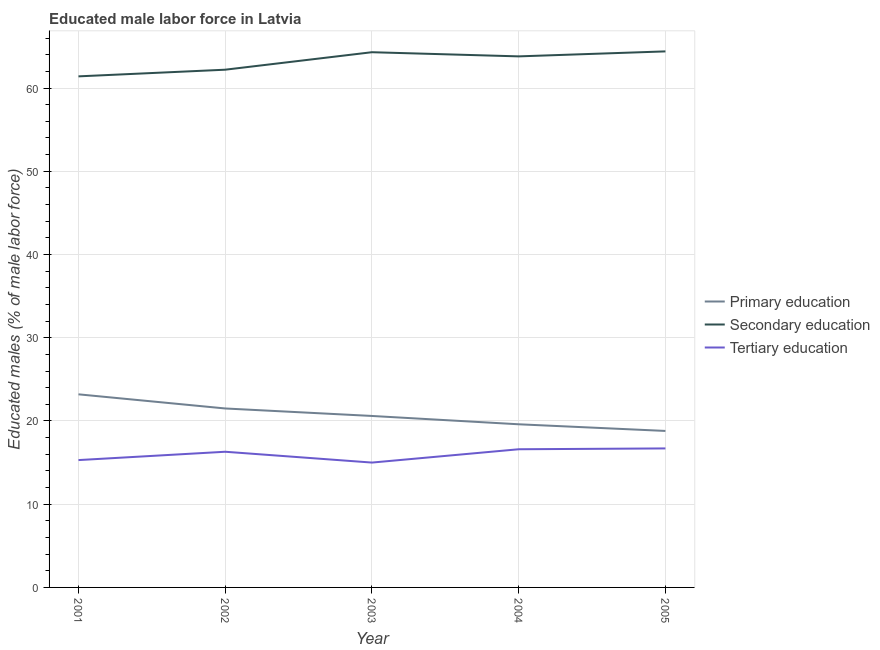Is the number of lines equal to the number of legend labels?
Provide a short and direct response. Yes. What is the percentage of male labor force who received secondary education in 2005?
Make the answer very short. 64.4. Across all years, what is the maximum percentage of male labor force who received primary education?
Your answer should be very brief. 23.2. Across all years, what is the minimum percentage of male labor force who received secondary education?
Keep it short and to the point. 61.4. In which year was the percentage of male labor force who received primary education maximum?
Offer a terse response. 2001. What is the total percentage of male labor force who received tertiary education in the graph?
Your response must be concise. 79.9. What is the difference between the percentage of male labor force who received secondary education in 2001 and that in 2003?
Ensure brevity in your answer.  -2.9. What is the difference between the percentage of male labor force who received tertiary education in 2004 and the percentage of male labor force who received secondary education in 2002?
Provide a short and direct response. -45.6. What is the average percentage of male labor force who received tertiary education per year?
Your answer should be compact. 15.98. In the year 2002, what is the difference between the percentage of male labor force who received primary education and percentage of male labor force who received secondary education?
Your response must be concise. -40.7. What is the ratio of the percentage of male labor force who received tertiary education in 2002 to that in 2005?
Ensure brevity in your answer.  0.98. Is the percentage of male labor force who received tertiary education in 2001 less than that in 2005?
Provide a succinct answer. Yes. What is the difference between the highest and the second highest percentage of male labor force who received tertiary education?
Keep it short and to the point. 0.1. What is the difference between the highest and the lowest percentage of male labor force who received tertiary education?
Keep it short and to the point. 1.7. In how many years, is the percentage of male labor force who received primary education greater than the average percentage of male labor force who received primary education taken over all years?
Give a very brief answer. 2. Is the sum of the percentage of male labor force who received tertiary education in 2002 and 2004 greater than the maximum percentage of male labor force who received secondary education across all years?
Provide a short and direct response. No. Does the percentage of male labor force who received tertiary education monotonically increase over the years?
Keep it short and to the point. No. Is the percentage of male labor force who received secondary education strictly less than the percentage of male labor force who received primary education over the years?
Offer a terse response. No. How many years are there in the graph?
Offer a very short reply. 5. What is the difference between two consecutive major ticks on the Y-axis?
Provide a short and direct response. 10. Are the values on the major ticks of Y-axis written in scientific E-notation?
Provide a succinct answer. No. Where does the legend appear in the graph?
Make the answer very short. Center right. How are the legend labels stacked?
Your response must be concise. Vertical. What is the title of the graph?
Provide a succinct answer. Educated male labor force in Latvia. What is the label or title of the X-axis?
Make the answer very short. Year. What is the label or title of the Y-axis?
Provide a short and direct response. Educated males (% of male labor force). What is the Educated males (% of male labor force) of Primary education in 2001?
Ensure brevity in your answer.  23.2. What is the Educated males (% of male labor force) of Secondary education in 2001?
Ensure brevity in your answer.  61.4. What is the Educated males (% of male labor force) of Tertiary education in 2001?
Offer a very short reply. 15.3. What is the Educated males (% of male labor force) of Primary education in 2002?
Give a very brief answer. 21.5. What is the Educated males (% of male labor force) of Secondary education in 2002?
Offer a terse response. 62.2. What is the Educated males (% of male labor force) in Tertiary education in 2002?
Keep it short and to the point. 16.3. What is the Educated males (% of male labor force) of Primary education in 2003?
Give a very brief answer. 20.6. What is the Educated males (% of male labor force) in Secondary education in 2003?
Your answer should be compact. 64.3. What is the Educated males (% of male labor force) in Tertiary education in 2003?
Offer a very short reply. 15. What is the Educated males (% of male labor force) of Primary education in 2004?
Keep it short and to the point. 19.6. What is the Educated males (% of male labor force) in Secondary education in 2004?
Provide a succinct answer. 63.8. What is the Educated males (% of male labor force) of Tertiary education in 2004?
Keep it short and to the point. 16.6. What is the Educated males (% of male labor force) of Primary education in 2005?
Offer a very short reply. 18.8. What is the Educated males (% of male labor force) of Secondary education in 2005?
Your answer should be compact. 64.4. What is the Educated males (% of male labor force) of Tertiary education in 2005?
Make the answer very short. 16.7. Across all years, what is the maximum Educated males (% of male labor force) of Primary education?
Offer a terse response. 23.2. Across all years, what is the maximum Educated males (% of male labor force) in Secondary education?
Offer a terse response. 64.4. Across all years, what is the maximum Educated males (% of male labor force) of Tertiary education?
Make the answer very short. 16.7. Across all years, what is the minimum Educated males (% of male labor force) in Primary education?
Your answer should be compact. 18.8. Across all years, what is the minimum Educated males (% of male labor force) of Secondary education?
Your response must be concise. 61.4. What is the total Educated males (% of male labor force) in Primary education in the graph?
Your answer should be compact. 103.7. What is the total Educated males (% of male labor force) of Secondary education in the graph?
Give a very brief answer. 316.1. What is the total Educated males (% of male labor force) of Tertiary education in the graph?
Your answer should be compact. 79.9. What is the difference between the Educated males (% of male labor force) in Primary education in 2001 and that in 2002?
Your response must be concise. 1.7. What is the difference between the Educated males (% of male labor force) of Secondary education in 2001 and that in 2002?
Give a very brief answer. -0.8. What is the difference between the Educated males (% of male labor force) of Tertiary education in 2001 and that in 2002?
Offer a very short reply. -1. What is the difference between the Educated males (% of male labor force) in Tertiary education in 2001 and that in 2003?
Keep it short and to the point. 0.3. What is the difference between the Educated males (% of male labor force) of Secondary education in 2002 and that in 2003?
Keep it short and to the point. -2.1. What is the difference between the Educated males (% of male labor force) in Tertiary education in 2002 and that in 2003?
Provide a short and direct response. 1.3. What is the difference between the Educated males (% of male labor force) of Tertiary education in 2002 and that in 2004?
Offer a terse response. -0.3. What is the difference between the Educated males (% of male labor force) of Secondary education in 2002 and that in 2005?
Ensure brevity in your answer.  -2.2. What is the difference between the Educated males (% of male labor force) of Primary education in 2003 and that in 2004?
Provide a short and direct response. 1. What is the difference between the Educated males (% of male labor force) in Secondary education in 2003 and that in 2004?
Offer a very short reply. 0.5. What is the difference between the Educated males (% of male labor force) of Tertiary education in 2003 and that in 2004?
Make the answer very short. -1.6. What is the difference between the Educated males (% of male labor force) of Primary education in 2003 and that in 2005?
Your answer should be very brief. 1.8. What is the difference between the Educated males (% of male labor force) of Secondary education in 2003 and that in 2005?
Provide a short and direct response. -0.1. What is the difference between the Educated males (% of male labor force) in Tertiary education in 2003 and that in 2005?
Make the answer very short. -1.7. What is the difference between the Educated males (% of male labor force) of Primary education in 2004 and that in 2005?
Offer a very short reply. 0.8. What is the difference between the Educated males (% of male labor force) in Tertiary education in 2004 and that in 2005?
Offer a very short reply. -0.1. What is the difference between the Educated males (% of male labor force) of Primary education in 2001 and the Educated males (% of male labor force) of Secondary education in 2002?
Keep it short and to the point. -39. What is the difference between the Educated males (% of male labor force) of Secondary education in 2001 and the Educated males (% of male labor force) of Tertiary education in 2002?
Give a very brief answer. 45.1. What is the difference between the Educated males (% of male labor force) of Primary education in 2001 and the Educated males (% of male labor force) of Secondary education in 2003?
Provide a short and direct response. -41.1. What is the difference between the Educated males (% of male labor force) in Primary education in 2001 and the Educated males (% of male labor force) in Tertiary education in 2003?
Provide a short and direct response. 8.2. What is the difference between the Educated males (% of male labor force) in Secondary education in 2001 and the Educated males (% of male labor force) in Tertiary education in 2003?
Provide a short and direct response. 46.4. What is the difference between the Educated males (% of male labor force) in Primary education in 2001 and the Educated males (% of male labor force) in Secondary education in 2004?
Give a very brief answer. -40.6. What is the difference between the Educated males (% of male labor force) of Secondary education in 2001 and the Educated males (% of male labor force) of Tertiary education in 2004?
Your answer should be compact. 44.8. What is the difference between the Educated males (% of male labor force) in Primary education in 2001 and the Educated males (% of male labor force) in Secondary education in 2005?
Offer a very short reply. -41.2. What is the difference between the Educated males (% of male labor force) of Primary education in 2001 and the Educated males (% of male labor force) of Tertiary education in 2005?
Your answer should be very brief. 6.5. What is the difference between the Educated males (% of male labor force) in Secondary education in 2001 and the Educated males (% of male labor force) in Tertiary education in 2005?
Provide a short and direct response. 44.7. What is the difference between the Educated males (% of male labor force) of Primary education in 2002 and the Educated males (% of male labor force) of Secondary education in 2003?
Your answer should be very brief. -42.8. What is the difference between the Educated males (% of male labor force) of Primary education in 2002 and the Educated males (% of male labor force) of Tertiary education in 2003?
Ensure brevity in your answer.  6.5. What is the difference between the Educated males (% of male labor force) in Secondary education in 2002 and the Educated males (% of male labor force) in Tertiary education in 2003?
Keep it short and to the point. 47.2. What is the difference between the Educated males (% of male labor force) in Primary education in 2002 and the Educated males (% of male labor force) in Secondary education in 2004?
Offer a terse response. -42.3. What is the difference between the Educated males (% of male labor force) of Secondary education in 2002 and the Educated males (% of male labor force) of Tertiary education in 2004?
Give a very brief answer. 45.6. What is the difference between the Educated males (% of male labor force) of Primary education in 2002 and the Educated males (% of male labor force) of Secondary education in 2005?
Keep it short and to the point. -42.9. What is the difference between the Educated males (% of male labor force) in Secondary education in 2002 and the Educated males (% of male labor force) in Tertiary education in 2005?
Your answer should be compact. 45.5. What is the difference between the Educated males (% of male labor force) of Primary education in 2003 and the Educated males (% of male labor force) of Secondary education in 2004?
Make the answer very short. -43.2. What is the difference between the Educated males (% of male labor force) in Secondary education in 2003 and the Educated males (% of male labor force) in Tertiary education in 2004?
Offer a terse response. 47.7. What is the difference between the Educated males (% of male labor force) in Primary education in 2003 and the Educated males (% of male labor force) in Secondary education in 2005?
Your response must be concise. -43.8. What is the difference between the Educated males (% of male labor force) in Secondary education in 2003 and the Educated males (% of male labor force) in Tertiary education in 2005?
Your response must be concise. 47.6. What is the difference between the Educated males (% of male labor force) of Primary education in 2004 and the Educated males (% of male labor force) of Secondary education in 2005?
Your answer should be compact. -44.8. What is the difference between the Educated males (% of male labor force) in Secondary education in 2004 and the Educated males (% of male labor force) in Tertiary education in 2005?
Give a very brief answer. 47.1. What is the average Educated males (% of male labor force) of Primary education per year?
Your answer should be compact. 20.74. What is the average Educated males (% of male labor force) of Secondary education per year?
Provide a short and direct response. 63.22. What is the average Educated males (% of male labor force) of Tertiary education per year?
Ensure brevity in your answer.  15.98. In the year 2001, what is the difference between the Educated males (% of male labor force) of Primary education and Educated males (% of male labor force) of Secondary education?
Provide a succinct answer. -38.2. In the year 2001, what is the difference between the Educated males (% of male labor force) in Primary education and Educated males (% of male labor force) in Tertiary education?
Provide a succinct answer. 7.9. In the year 2001, what is the difference between the Educated males (% of male labor force) of Secondary education and Educated males (% of male labor force) of Tertiary education?
Make the answer very short. 46.1. In the year 2002, what is the difference between the Educated males (% of male labor force) in Primary education and Educated males (% of male labor force) in Secondary education?
Ensure brevity in your answer.  -40.7. In the year 2002, what is the difference between the Educated males (% of male labor force) of Secondary education and Educated males (% of male labor force) of Tertiary education?
Your answer should be very brief. 45.9. In the year 2003, what is the difference between the Educated males (% of male labor force) in Primary education and Educated males (% of male labor force) in Secondary education?
Keep it short and to the point. -43.7. In the year 2003, what is the difference between the Educated males (% of male labor force) in Secondary education and Educated males (% of male labor force) in Tertiary education?
Provide a short and direct response. 49.3. In the year 2004, what is the difference between the Educated males (% of male labor force) of Primary education and Educated males (% of male labor force) of Secondary education?
Your answer should be very brief. -44.2. In the year 2004, what is the difference between the Educated males (% of male labor force) of Secondary education and Educated males (% of male labor force) of Tertiary education?
Make the answer very short. 47.2. In the year 2005, what is the difference between the Educated males (% of male labor force) in Primary education and Educated males (% of male labor force) in Secondary education?
Your response must be concise. -45.6. In the year 2005, what is the difference between the Educated males (% of male labor force) in Secondary education and Educated males (% of male labor force) in Tertiary education?
Provide a succinct answer. 47.7. What is the ratio of the Educated males (% of male labor force) of Primary education in 2001 to that in 2002?
Offer a terse response. 1.08. What is the ratio of the Educated males (% of male labor force) in Secondary education in 2001 to that in 2002?
Ensure brevity in your answer.  0.99. What is the ratio of the Educated males (% of male labor force) in Tertiary education in 2001 to that in 2002?
Offer a very short reply. 0.94. What is the ratio of the Educated males (% of male labor force) of Primary education in 2001 to that in 2003?
Make the answer very short. 1.13. What is the ratio of the Educated males (% of male labor force) of Secondary education in 2001 to that in 2003?
Provide a short and direct response. 0.95. What is the ratio of the Educated males (% of male labor force) of Tertiary education in 2001 to that in 2003?
Provide a succinct answer. 1.02. What is the ratio of the Educated males (% of male labor force) in Primary education in 2001 to that in 2004?
Keep it short and to the point. 1.18. What is the ratio of the Educated males (% of male labor force) in Secondary education in 2001 to that in 2004?
Provide a short and direct response. 0.96. What is the ratio of the Educated males (% of male labor force) of Tertiary education in 2001 to that in 2004?
Give a very brief answer. 0.92. What is the ratio of the Educated males (% of male labor force) of Primary education in 2001 to that in 2005?
Ensure brevity in your answer.  1.23. What is the ratio of the Educated males (% of male labor force) in Secondary education in 2001 to that in 2005?
Provide a short and direct response. 0.95. What is the ratio of the Educated males (% of male labor force) of Tertiary education in 2001 to that in 2005?
Provide a short and direct response. 0.92. What is the ratio of the Educated males (% of male labor force) of Primary education in 2002 to that in 2003?
Make the answer very short. 1.04. What is the ratio of the Educated males (% of male labor force) in Secondary education in 2002 to that in 2003?
Keep it short and to the point. 0.97. What is the ratio of the Educated males (% of male labor force) in Tertiary education in 2002 to that in 2003?
Ensure brevity in your answer.  1.09. What is the ratio of the Educated males (% of male labor force) in Primary education in 2002 to that in 2004?
Ensure brevity in your answer.  1.1. What is the ratio of the Educated males (% of male labor force) in Secondary education in 2002 to that in 2004?
Your answer should be compact. 0.97. What is the ratio of the Educated males (% of male labor force) in Tertiary education in 2002 to that in 2004?
Provide a short and direct response. 0.98. What is the ratio of the Educated males (% of male labor force) of Primary education in 2002 to that in 2005?
Keep it short and to the point. 1.14. What is the ratio of the Educated males (% of male labor force) of Secondary education in 2002 to that in 2005?
Provide a short and direct response. 0.97. What is the ratio of the Educated males (% of male labor force) in Primary education in 2003 to that in 2004?
Keep it short and to the point. 1.05. What is the ratio of the Educated males (% of male labor force) in Tertiary education in 2003 to that in 2004?
Ensure brevity in your answer.  0.9. What is the ratio of the Educated males (% of male labor force) of Primary education in 2003 to that in 2005?
Your answer should be very brief. 1.1. What is the ratio of the Educated males (% of male labor force) of Tertiary education in 2003 to that in 2005?
Offer a terse response. 0.9. What is the ratio of the Educated males (% of male labor force) in Primary education in 2004 to that in 2005?
Give a very brief answer. 1.04. What is the difference between the highest and the second highest Educated males (% of male labor force) of Primary education?
Ensure brevity in your answer.  1.7. What is the difference between the highest and the second highest Educated males (% of male labor force) in Secondary education?
Your answer should be very brief. 0.1. What is the difference between the highest and the second highest Educated males (% of male labor force) of Tertiary education?
Offer a terse response. 0.1. What is the difference between the highest and the lowest Educated males (% of male labor force) of Secondary education?
Make the answer very short. 3. What is the difference between the highest and the lowest Educated males (% of male labor force) of Tertiary education?
Offer a terse response. 1.7. 